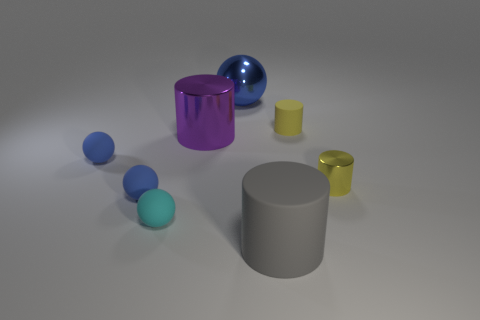Subtract all purple cylinders. How many blue balls are left? 3 Subtract 1 balls. How many balls are left? 3 Add 1 small purple cylinders. How many objects exist? 9 Add 5 gray things. How many gray things exist? 6 Subtract 1 purple cylinders. How many objects are left? 7 Subtract all tiny cyan balls. Subtract all tiny yellow matte cylinders. How many objects are left? 6 Add 5 shiny spheres. How many shiny spheres are left? 6 